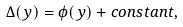Convert formula to latex. <formula><loc_0><loc_0><loc_500><loc_500>\Delta ( y ) = \phi ( y ) + c o n s t a n t ,</formula> 